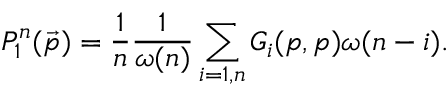Convert formula to latex. <formula><loc_0><loc_0><loc_500><loc_500>P _ { 1 } ^ { n } ( \vec { p } ) = \frac { 1 } { n } \frac { 1 } { \omega ( n ) } \sum _ { i = 1 , n } G _ { i } ( p , p ) \omega ( n - i ) .</formula> 